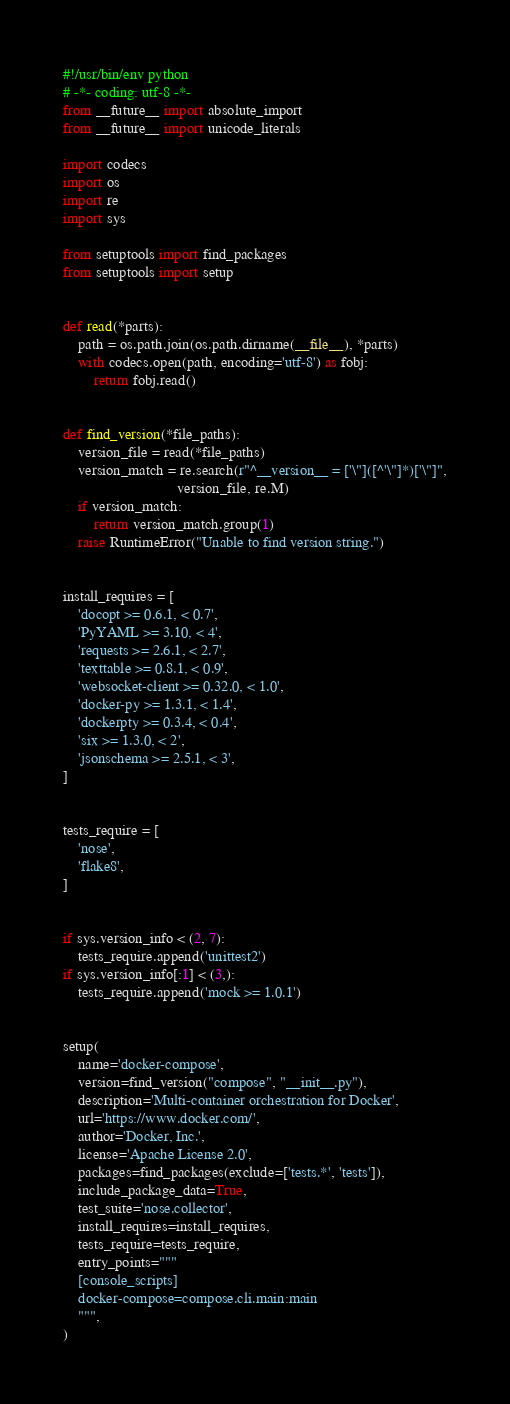<code> <loc_0><loc_0><loc_500><loc_500><_Python_>#!/usr/bin/env python
# -*- coding: utf-8 -*-
from __future__ import absolute_import
from __future__ import unicode_literals

import codecs
import os
import re
import sys

from setuptools import find_packages
from setuptools import setup


def read(*parts):
    path = os.path.join(os.path.dirname(__file__), *parts)
    with codecs.open(path, encoding='utf-8') as fobj:
        return fobj.read()


def find_version(*file_paths):
    version_file = read(*file_paths)
    version_match = re.search(r"^__version__ = ['\"]([^'\"]*)['\"]",
                              version_file, re.M)
    if version_match:
        return version_match.group(1)
    raise RuntimeError("Unable to find version string.")


install_requires = [
    'docopt >= 0.6.1, < 0.7',
    'PyYAML >= 3.10, < 4',
    'requests >= 2.6.1, < 2.7',
    'texttable >= 0.8.1, < 0.9',
    'websocket-client >= 0.32.0, < 1.0',
    'docker-py >= 1.3.1, < 1.4',
    'dockerpty >= 0.3.4, < 0.4',
    'six >= 1.3.0, < 2',
    'jsonschema >= 2.5.1, < 3',
]


tests_require = [
    'nose',
    'flake8',
]


if sys.version_info < (2, 7):
    tests_require.append('unittest2')
if sys.version_info[:1] < (3,):
    tests_require.append('mock >= 1.0.1')


setup(
    name='docker-compose',
    version=find_version("compose", "__init__.py"),
    description='Multi-container orchestration for Docker',
    url='https://www.docker.com/',
    author='Docker, Inc.',
    license='Apache License 2.0',
    packages=find_packages(exclude=['tests.*', 'tests']),
    include_package_data=True,
    test_suite='nose.collector',
    install_requires=install_requires,
    tests_require=tests_require,
    entry_points="""
    [console_scripts]
    docker-compose=compose.cli.main:main
    """,
)
</code> 